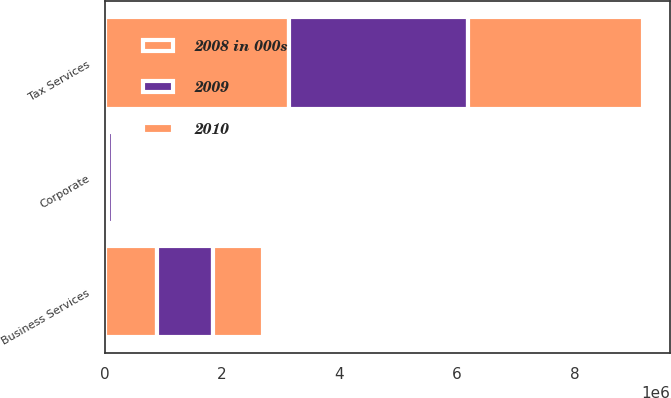Convert chart. <chart><loc_0><loc_0><loc_500><loc_500><stacked_bar_chart><ecel><fcel>Tax Services<fcel>Business Services<fcel>Corporate<nl><fcel>2010<fcel>2.97525e+06<fcel>860349<fcel>38731<nl><fcel>2008 in 000s<fcel>3.13208e+06<fcel>897809<fcel>53691<nl><fcel>2009<fcel>3.06066e+06<fcel>941686<fcel>84283<nl></chart> 